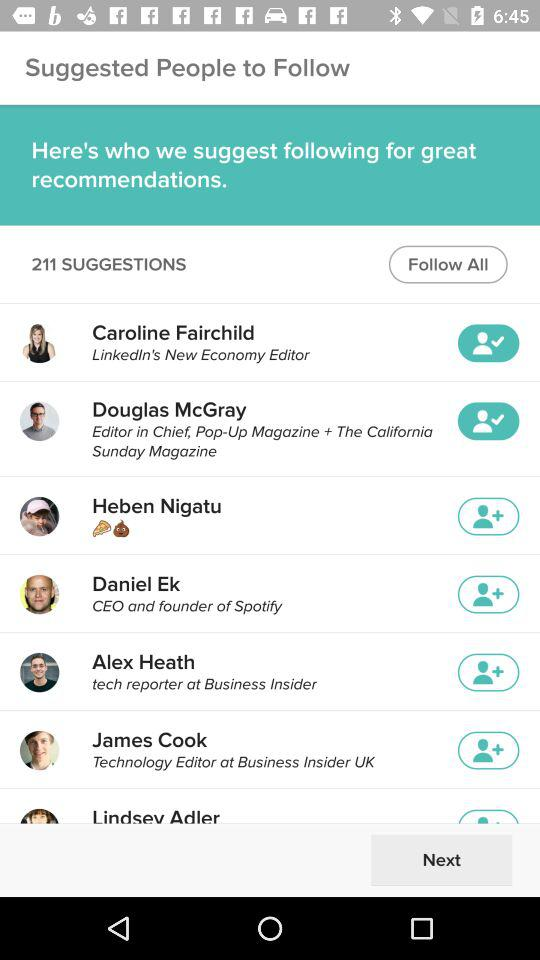What is the designation of the "James Cook"? The designation is "Technology Editor ". 